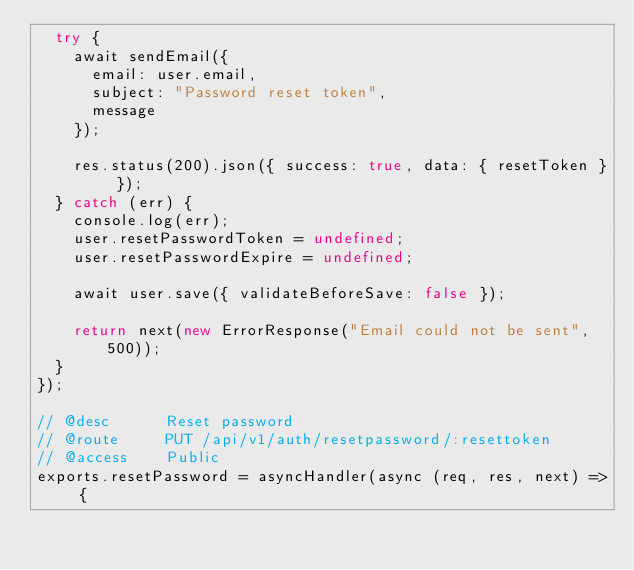Convert code to text. <code><loc_0><loc_0><loc_500><loc_500><_JavaScript_>  try {
    await sendEmail({
      email: user.email,
      subject: "Password reset token",
      message
    });

    res.status(200).json({ success: true, data: { resetToken } });
  } catch (err) {
    console.log(err);
    user.resetPasswordToken = undefined;
    user.resetPasswordExpire = undefined;

    await user.save({ validateBeforeSave: false });

    return next(new ErrorResponse("Email could not be sent", 500));
  }
});

// @desc      Reset password
// @route     PUT /api/v1/auth/resetpassword/:resettoken
// @access    Public
exports.resetPassword = asyncHandler(async (req, res, next) => {</code> 